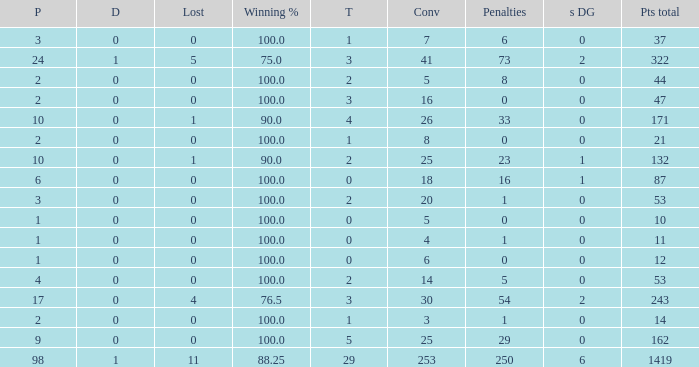How many ties did he have when he had 1 penalties and more than 20 conversions? None. 